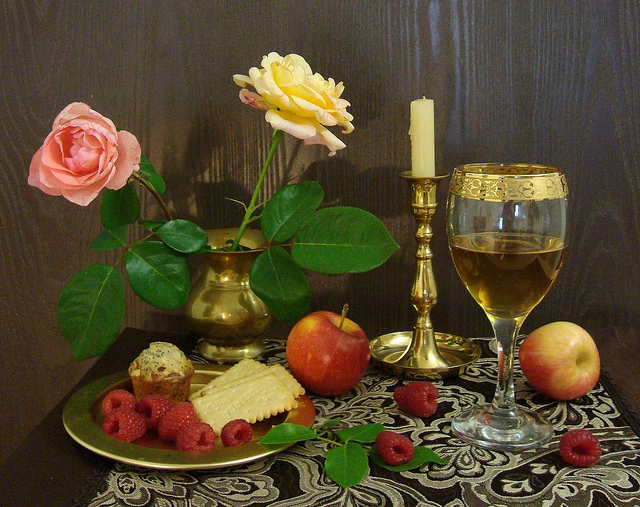<image>How many persimmons are in the display? I don't know how many persimmons are in the display. How many persimmons are in the display? It is not clear how many persimmons are in the display. It can be seen 0, 1, 2 or 3 persimmons. 